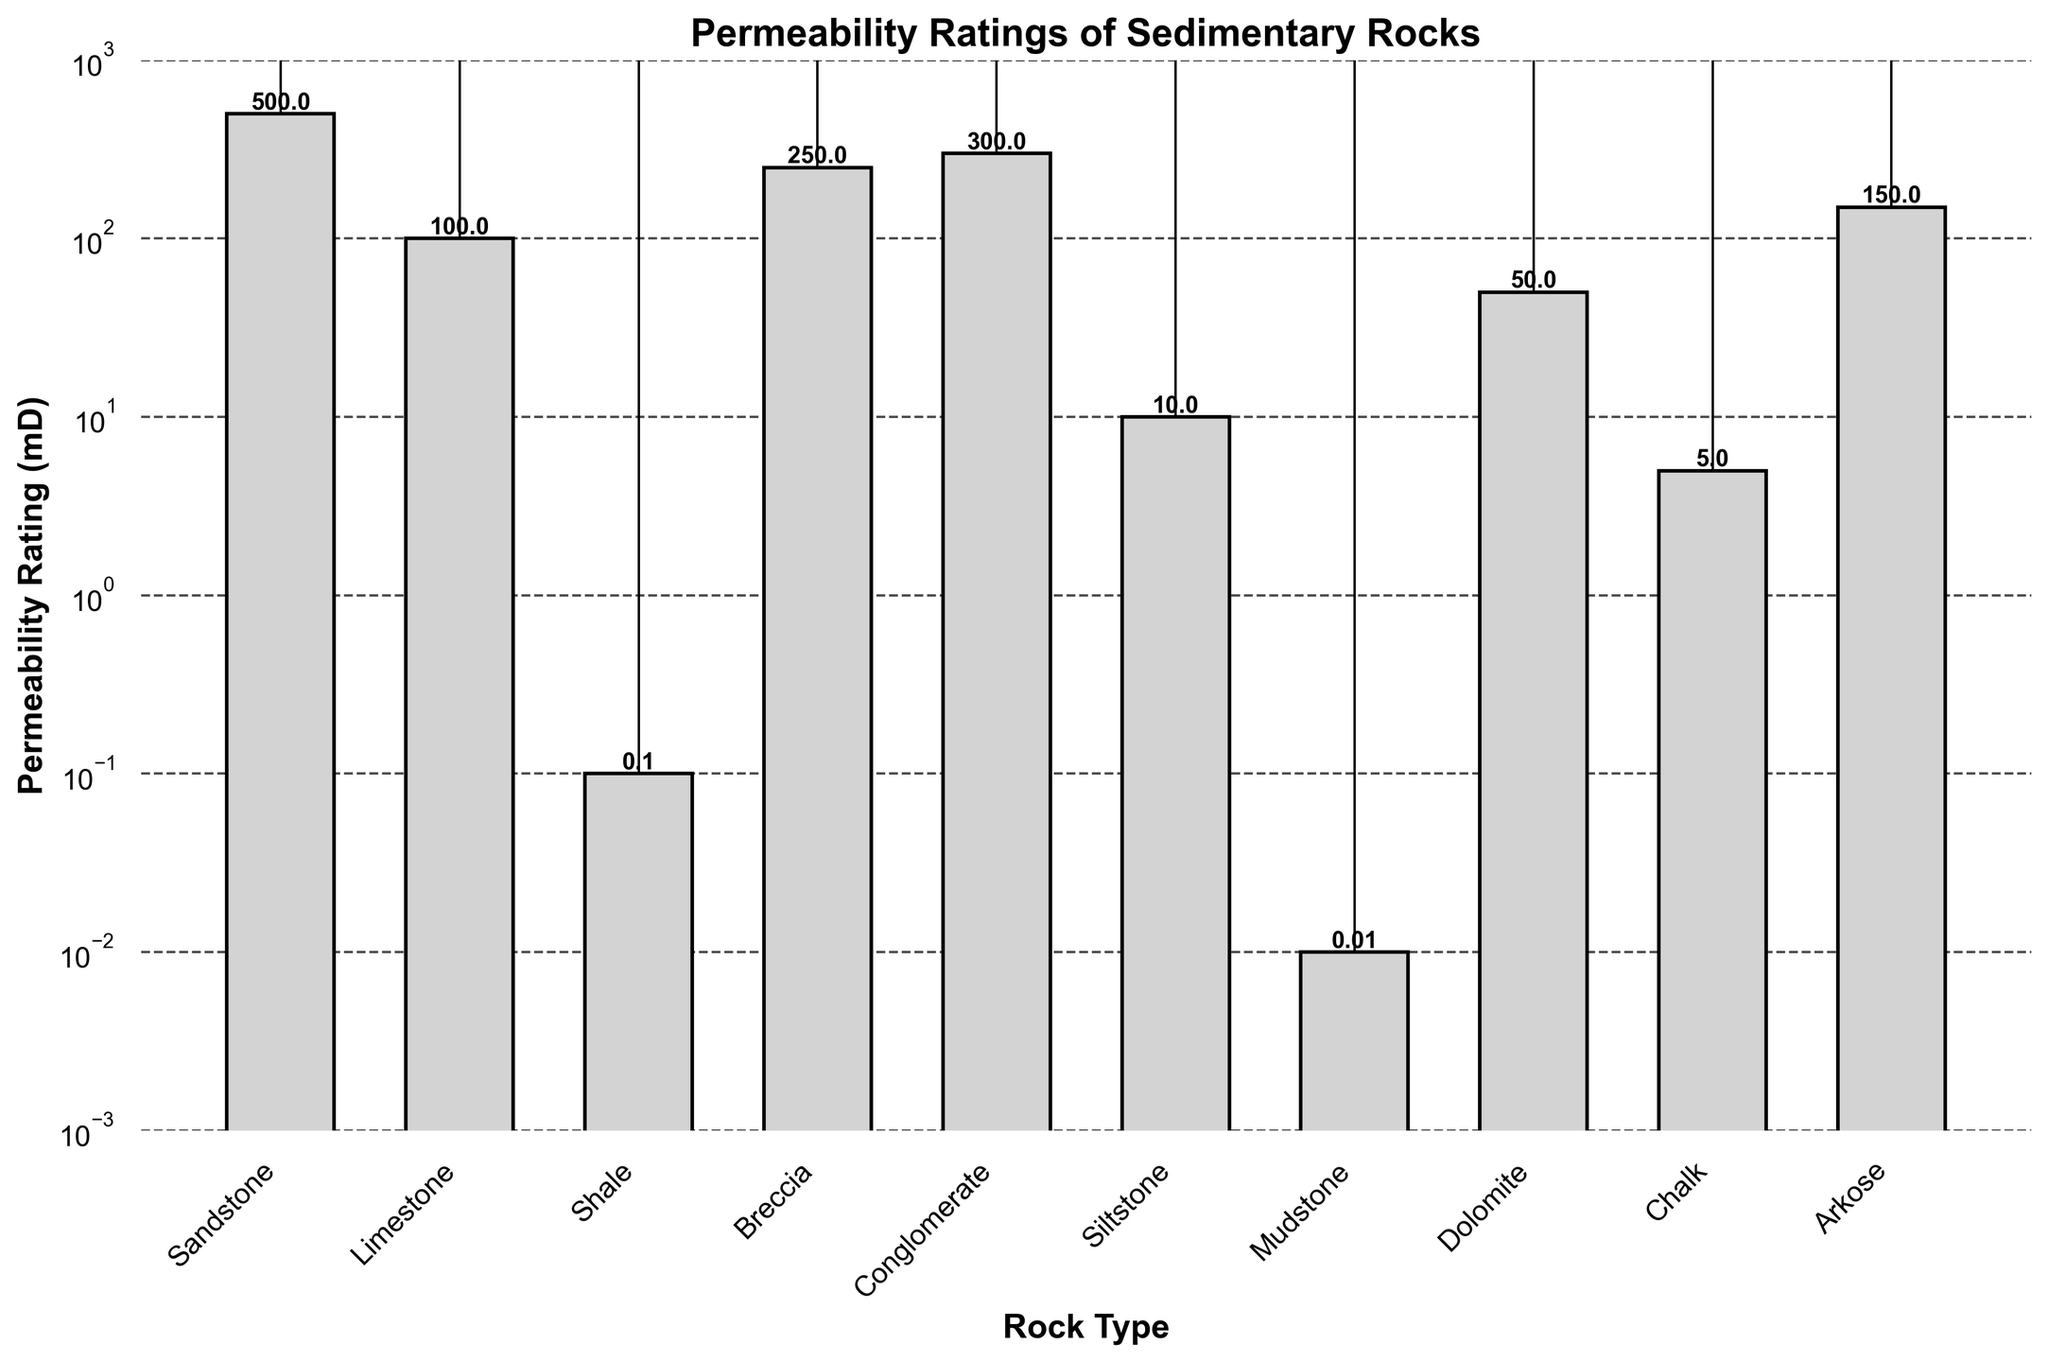What is the rock type with the highest permeability rating? The rock types and their permeability ratings are shown in the figure. The tallest bar represents the highest permeability rating, which is 500 mD. This corresponds to Sandstone.
Answer: Sandstone Which rock type has the lowest permeability rating? Observing the figure, the shortest bar represents the lowest permeability rating, which is 0.01 mD. This corresponds to Mudstone.
Answer: Mudstone How many rock types have a permeability rating higher than 100 mD? By counting the bars that are higher than the 100 mD mark on the y-axis, we have Sandstone (500 mD), Breccia (250 mD), Conglomerate (300 mD), and Arkose (150 mD). These are four rock types.
Answer: 4 What is the average permeability rating of Sandstone, Limestone, and Shale? The permeability ratings for Sandstone, Limestone, and Shale are 500, 100, and 0.1 mD respectively. The average is calculated as (500 + 100 + 0.1) / 3 = 200.0333 mD.
Answer: 200.0333 mD Compare the permeability ratings of Dolomite and Chalk. Which one is higher and by how much? The permeability rating for Dolomite is 50 mD whereas for Chalk it is 5 mD. The difference between them is 50 - 5 = 45 mD. Dolomite has a higher permeability rating by 45 mD.
Answer: Dolomite by 45 mD How does the permeability rating of Siltstone compare to that of Arkose? The permeability rating for Siltstone is 10 mD, while for Arkose it is 150 mD. Comparing these, Siltstone has a lower permeability rating than Arkose by 140 mD.
Answer: Arkose has a higher permeability rating What are the rock types with a permeability rating less than 10 mD? Observing the figure, the rock types with bars shorter than the 10 mD mark are Shale (0.1 mD) and Mudstone (0.01 mD).
Answer: Shale and Mudstone Calculate the total permeability rating of rocks with ratings above 300 mD. Only Sandstone with 500 mD has a rating above 300 mD. So, the total is 500.
Answer: 500 mD Which rock type has a permeability rating closest to the median permeability rating of all rock types? First, arrange the permeability ratings in ascending order: 0.01, 0.1, 5, 10, 50, 100, 150, 250, 300, 500. The median permeability rating is the average of the 5th and 6th values, which is (50 + 100) / 2 = 75 mD. Dolomite with a permeability rating of 50 mD is closest to this median.
Answer: Dolomite What is the range of permeability ratings among the rock types? The range is calculated by subtracting the smallest value from the largest value. The highest rating is 500 mD (Sandstone) and the lowest is 0.01 mD (Mudstone). Thus, the range is 500 - 0.01 = 499.99 mD.
Answer: 499.99 mD 